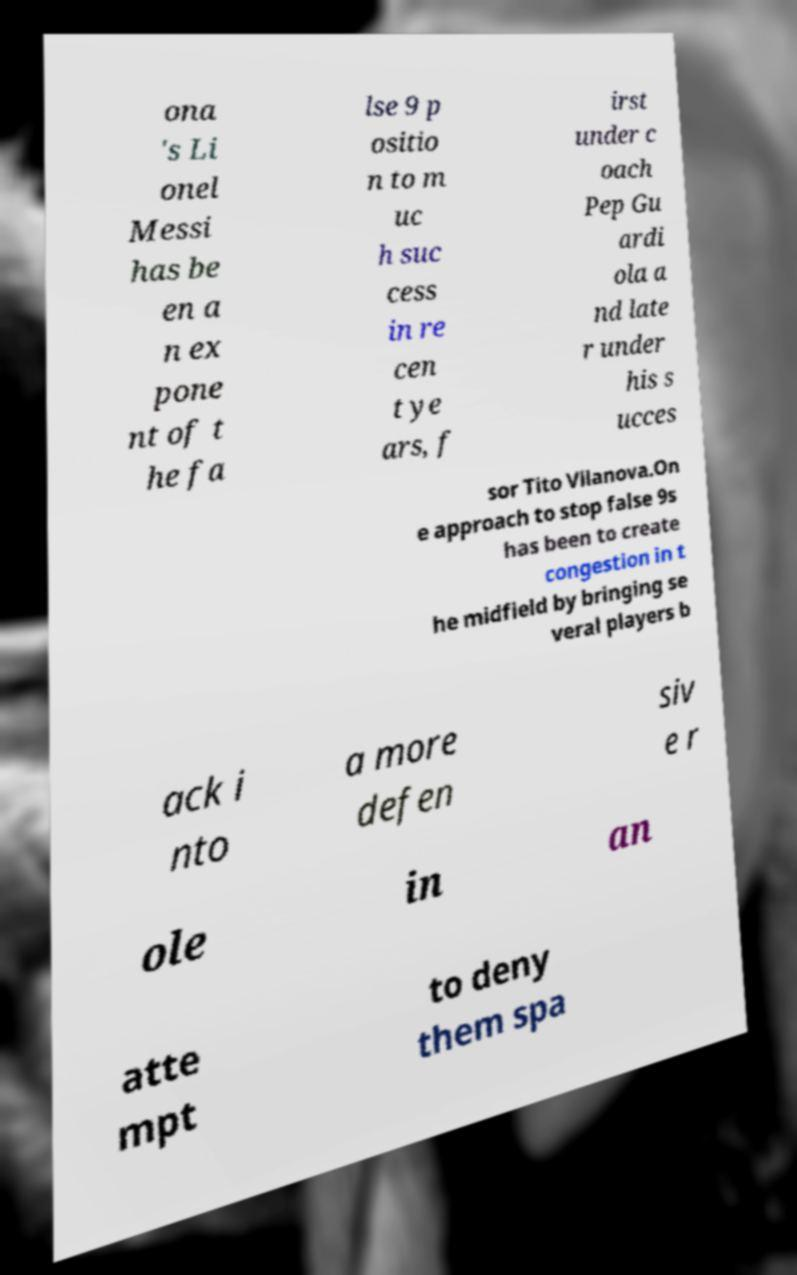What strategies does the text suggest for countering the 'false 9' position in football, as used by Lionel Messi? The text discusses a tactical approach to manage a 'false 9' like Lionel Messi by creating congestion in the midfield. This strategy involves bringing several players back into more defensive roles to limit the space and opportunities for the 'false 9' to operate effectively. 